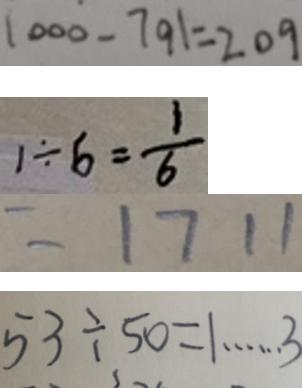Convert formula to latex. <formula><loc_0><loc_0><loc_500><loc_500>1 0 0 0 - 7 9 1 = 2 0 9 
 1 \div 6 = \frac { 1 } { 6 } 
 = 1 7 1 1 
 5 3 \div 5 0 = 1 \cdots 3</formula> 